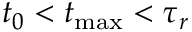<formula> <loc_0><loc_0><loc_500><loc_500>t _ { 0 } < t _ { \max } < \tau _ { r }</formula> 